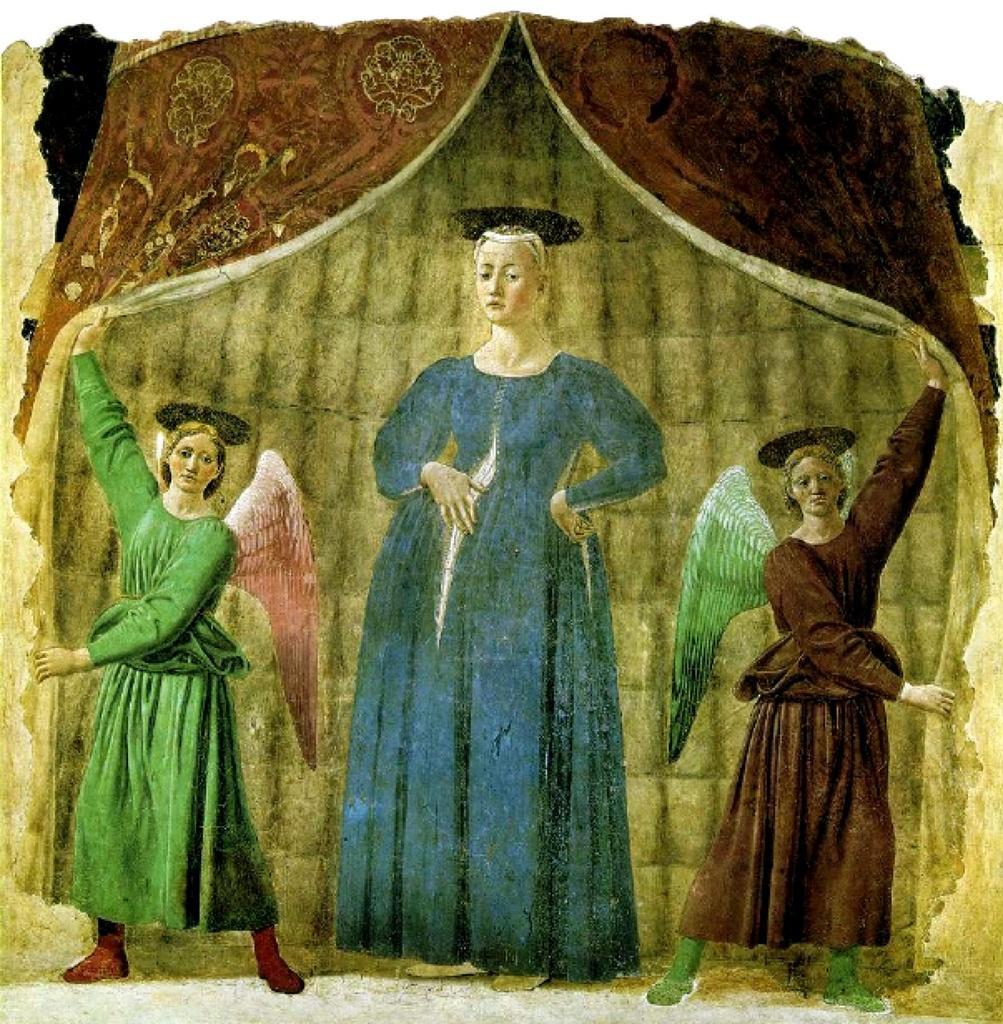Could you give a brief overview of what you see in this image? In this image I can see depiction picture of three women and of curtains. 